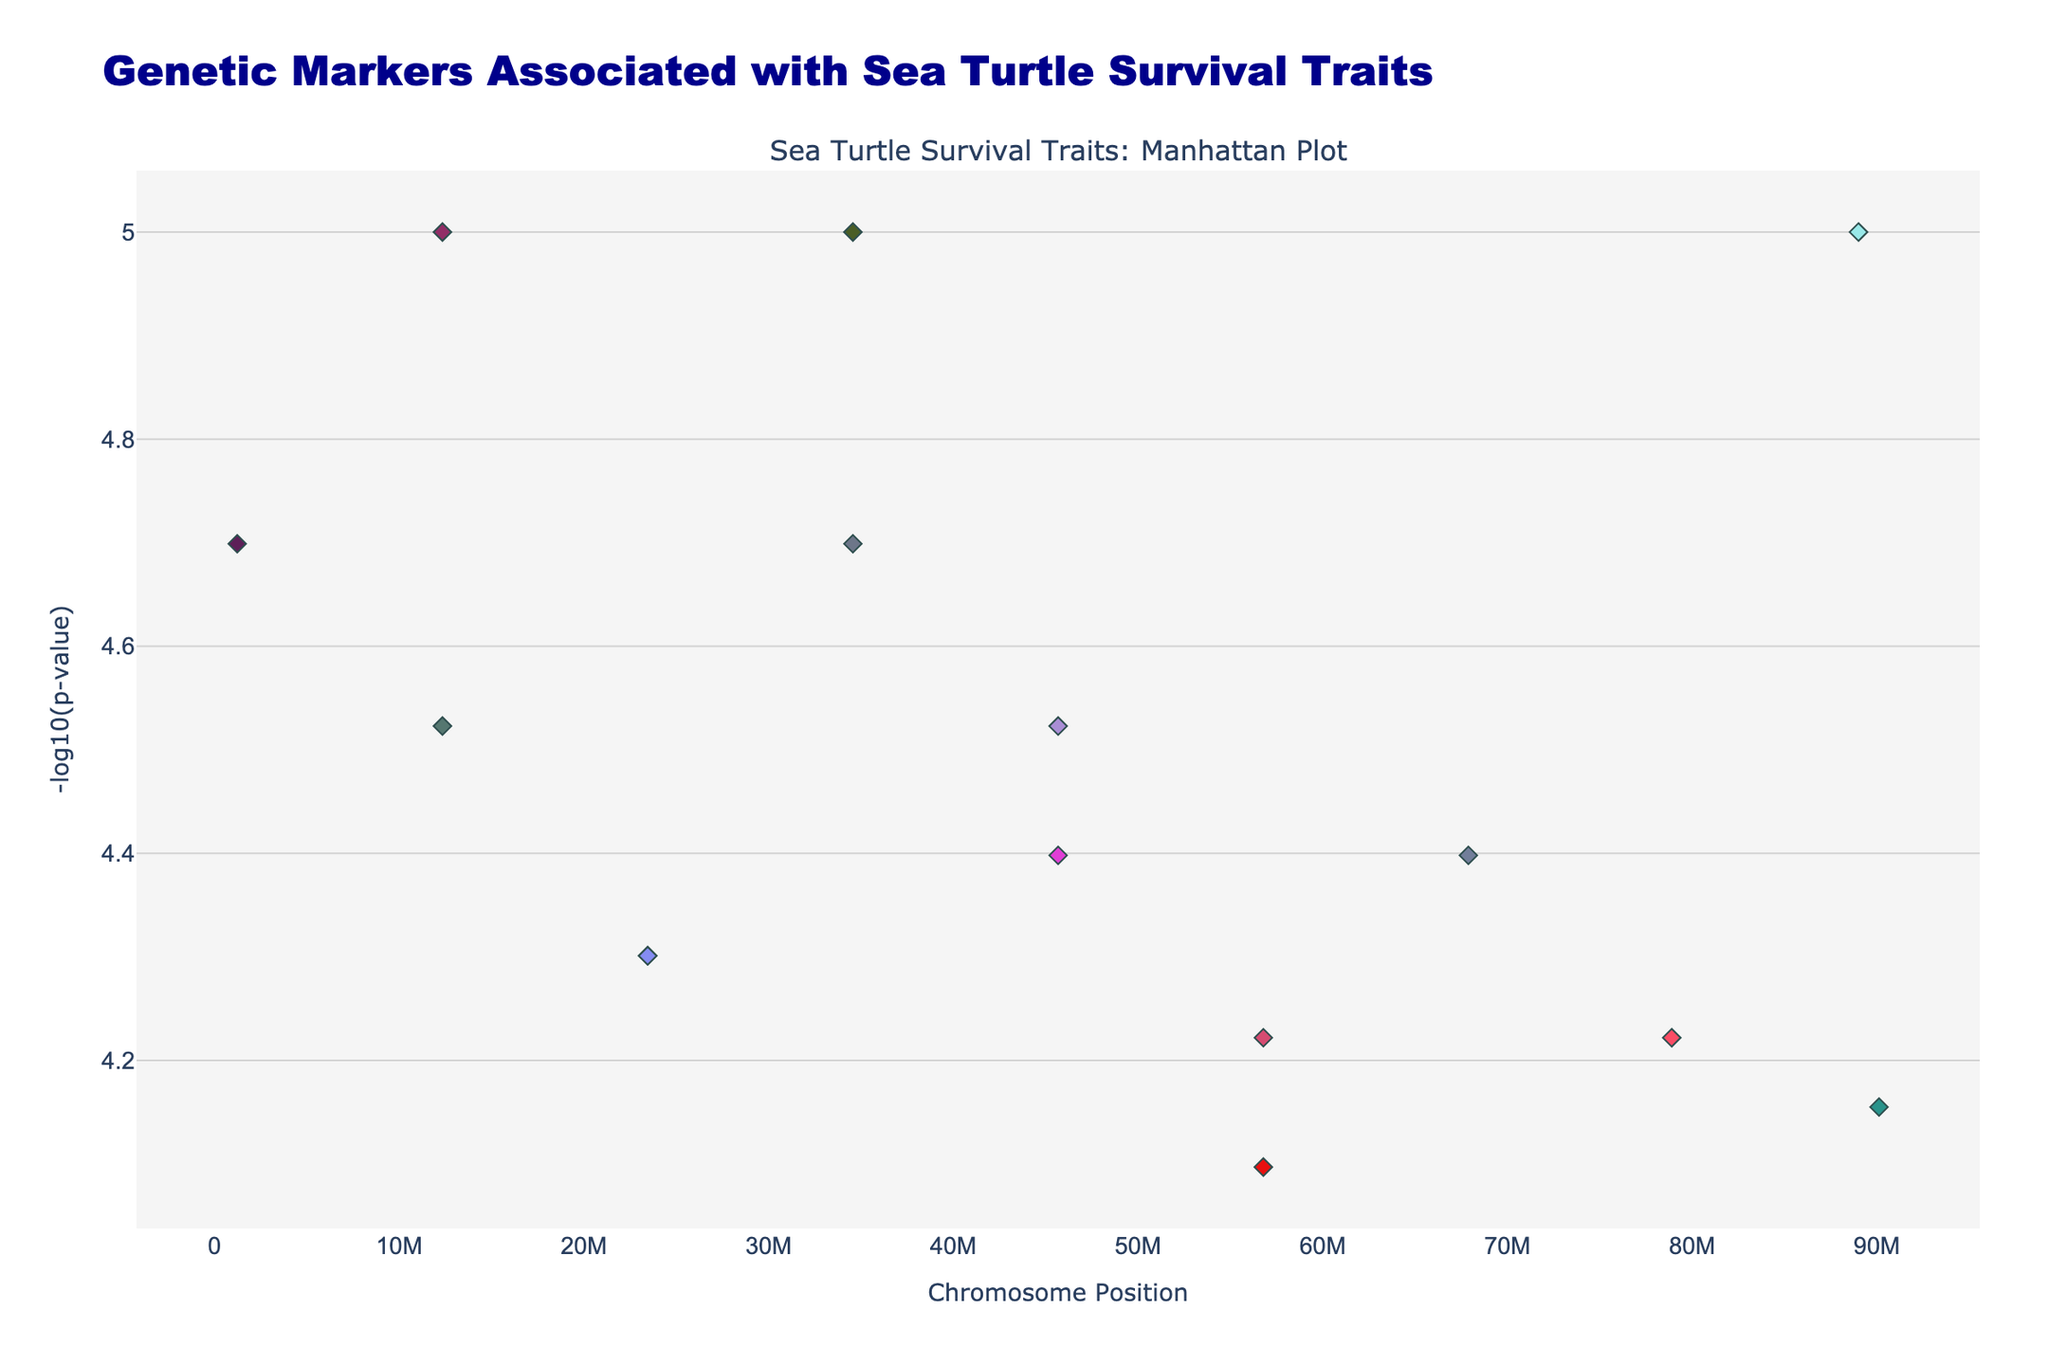What's the title of the plot? The title of the plot is displayed at the top of the figure in larger, bold font.
Answer: Genetic Markers Associated with Sea Turtle Survival Traits What does the x-axis represent in the plot? Observing the x-axis label at the bottom of the plot, it represents the positions on the chromosomes where the SNPs are located.
Answer: Chromosome Position How is the significance of the SNPs visually represented? The significance of the SNPs is represented by the y-axis values, which are the -log10(p-value); higher y-values indicate more significant SNPs.
Answer: By the y-axis as -log10(p-value) Which SNP has the highest significance? Looking at the highest point on the plot and identifying the SNP positioned at that point, we find rs1234567 (Trait: Shell_hardness) on Chromosome 1.
Answer: rs1234567 How many distinct traits are included in the plot? By checking the legend section, we can count the unique traits listed.
Answer: 15 Which trait is associated with the SNP that has the smallest p-value on Chromosome 8? By finding the SNP with the color, and then its -log10(p-value) on Chromosome 8 and matching it to the trait, we see the trait related to Bycatch_resistance.
Answer: Bycatch_resistance Compare the SNP significance between Chromosome 5 and Chromosome 10. Identify the points on Chromosome 5 and Chromosome 10 to compare their -log10(p-value); Chromosome 5 has a significant point with a -log10(p-value) lower, indicating less significance compared to Chromosome 10.
Answer: Chromosome 10 has higher SNP significance Which chromosomes have SNPs with a -log10(p-value) greater than 4? Referencing the points on the plot above the y-axis value of 4, we identify the chromosomes containing these points, which are 1, 3, 4, 8, and 13.
Answer: Chromosomes 1, 3, 4, 8, and 13 What trait is represented by the SNP with the symbol 'diamond' on Chromosome 3? Identify the 'diamond' symbol in Chromosome 3's section, and use the hover info or legend to determine the trait. The SNP 'rs3456789' related to Temperature_tolerance matches 'diamond' from the trait list.
Answer: Temperature_tolerance What is the -log10(p-value) for SNP associated with Shell_hardness? Locate the SNP rs1234567 for Shell_hardness and read its corresponding y-value to determine the -log10(p-value).
Answer: 5 